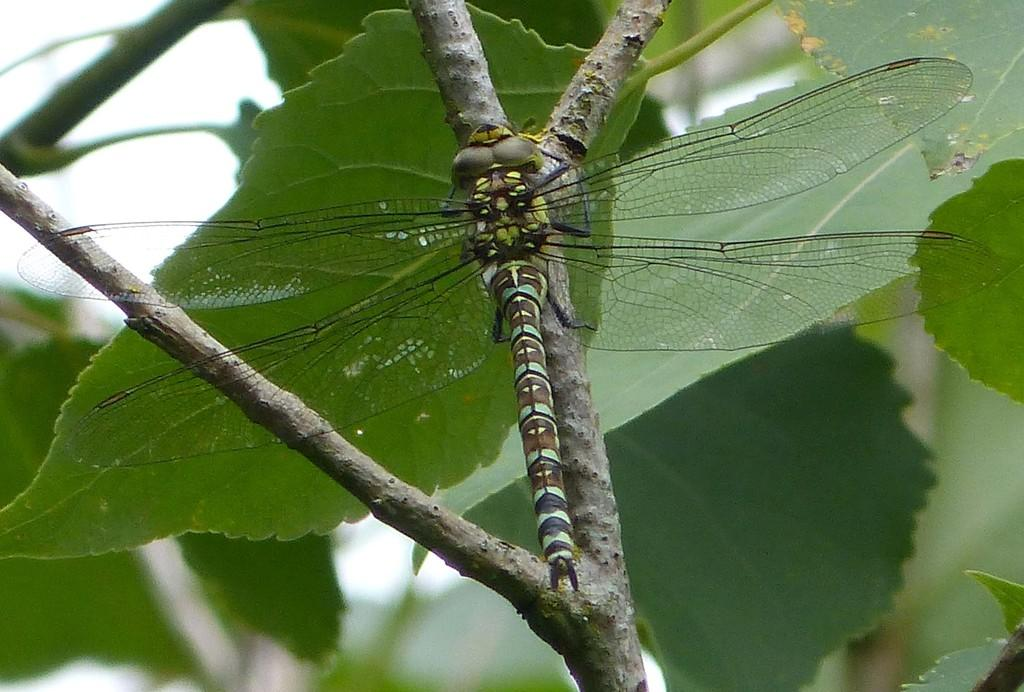What insect is present in the image? There is a dragonfly in the image. Where is the dragonfly located on the plant? The dragonfly is on the stem of a plant. What can be seen in the background of the image? There are leaves and the sky visible in the background of the image. What order of insects does the dragonfly belong to in the image? The image does not provide information about the order of insects to which the dragonfly belongs. 